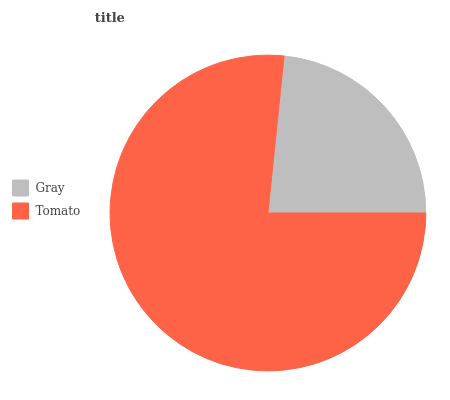Is Gray the minimum?
Answer yes or no. Yes. Is Tomato the maximum?
Answer yes or no. Yes. Is Tomato the minimum?
Answer yes or no. No. Is Tomato greater than Gray?
Answer yes or no. Yes. Is Gray less than Tomato?
Answer yes or no. Yes. Is Gray greater than Tomato?
Answer yes or no. No. Is Tomato less than Gray?
Answer yes or no. No. Is Tomato the high median?
Answer yes or no. Yes. Is Gray the low median?
Answer yes or no. Yes. Is Gray the high median?
Answer yes or no. No. Is Tomato the low median?
Answer yes or no. No. 